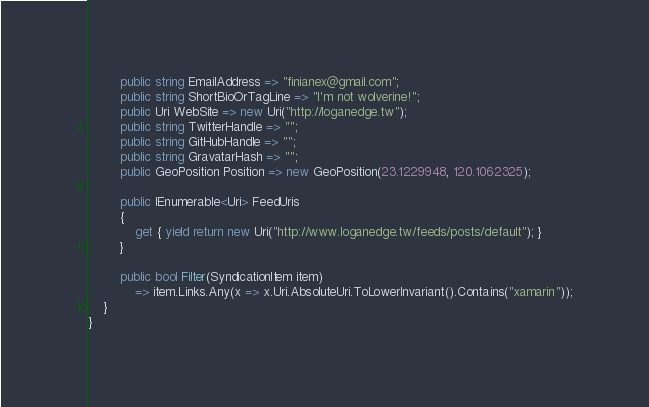Convert code to text. <code><loc_0><loc_0><loc_500><loc_500><_C#_>        public string EmailAddress => "finianex@gmail.com";
        public string ShortBioOrTagLine => "I'm not wolverine!";
        public Uri WebSite => new Uri("http://loganedge.tw");
        public string TwitterHandle => "";
        public string GitHubHandle => "";
        public string GravatarHash => "";
        public GeoPosition Position => new GeoPosition(23.1229948, 120.1062325);

        public IEnumerable<Uri> FeedUris
        {
            get { yield return new Uri("http://www.loganedge.tw/feeds/posts/default"); }
        }

        public bool Filter(SyndicationItem item)
            => item.Links.Any(x => x.Uri.AbsoluteUri.ToLowerInvariant().Contains("xamarin"));
    }
}
</code> 